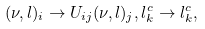Convert formula to latex. <formula><loc_0><loc_0><loc_500><loc_500>( \nu , l ) _ { i } \to U _ { i j } ( \nu , l ) _ { j } , l ^ { c } _ { k } \to l ^ { c } _ { k } ,</formula> 